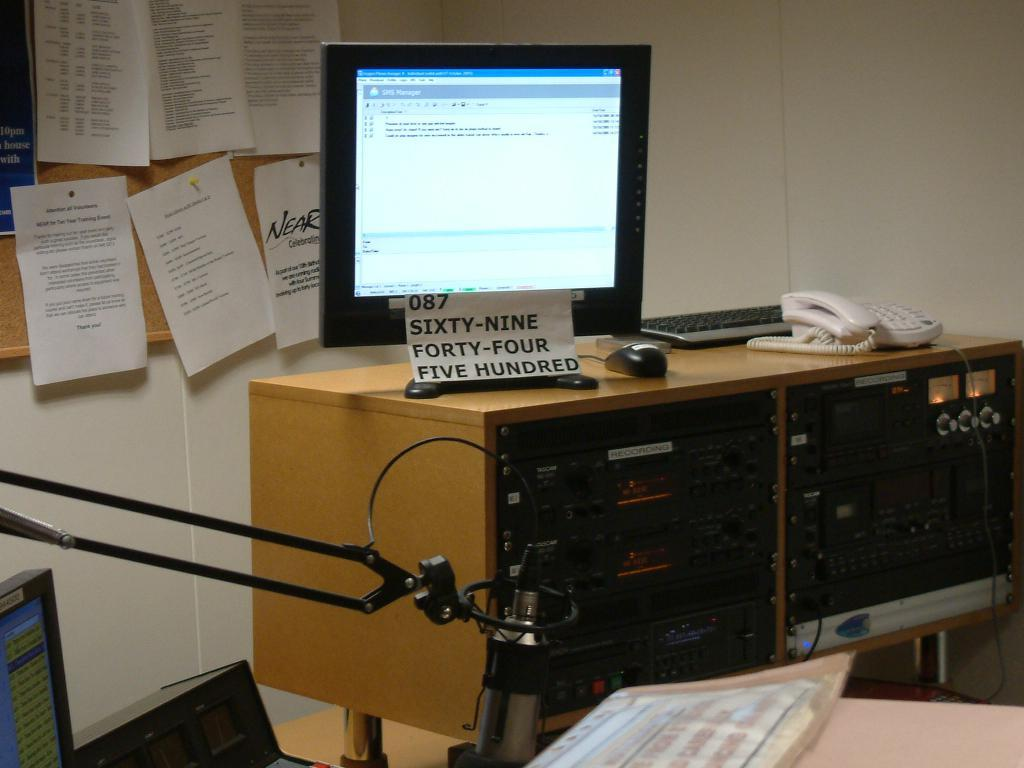What electronic device is visible in the image? There is a monitor in the image. Where was the image taken? The image was taken inside a room. What can be seen on the left side of the image? There is a wall to the left in the image. What is attached to the wall? A wooden board is present on the wall. What is placed on the wooden board? Papers are fixed on the wooden board. What type of quartz is used as a decorative element in the image? There is no quartz present in the image. How does the person in the image react to the cough of another person? There is no person present in the image, so it is impossible to determine their reaction to a cough. 